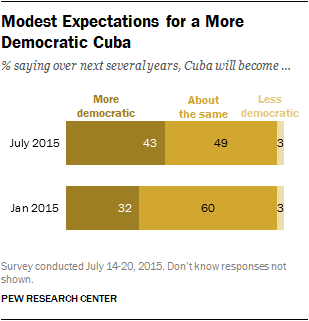Outline some significant characteristics in this image. The option that changes the most is the one that is more democratic. What's the most popular response in the chart? The most popular response in the chart is about the same. 